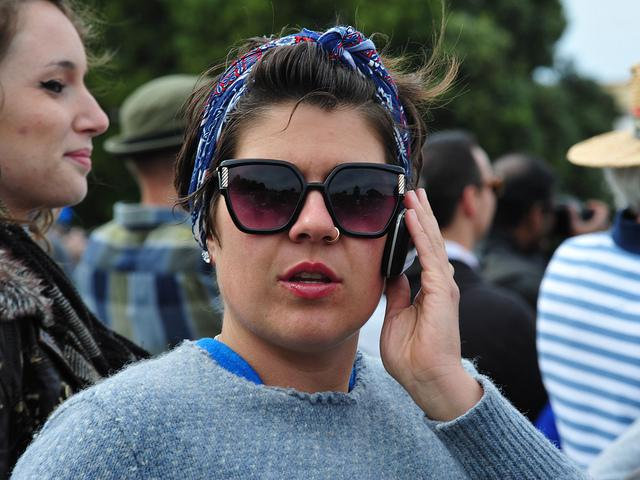What is the most likely purpose for the glasses on the girls face?

Choices:
A) hide hangover
B) cool color
C) extra weight
D) blocking sun blocking sun 